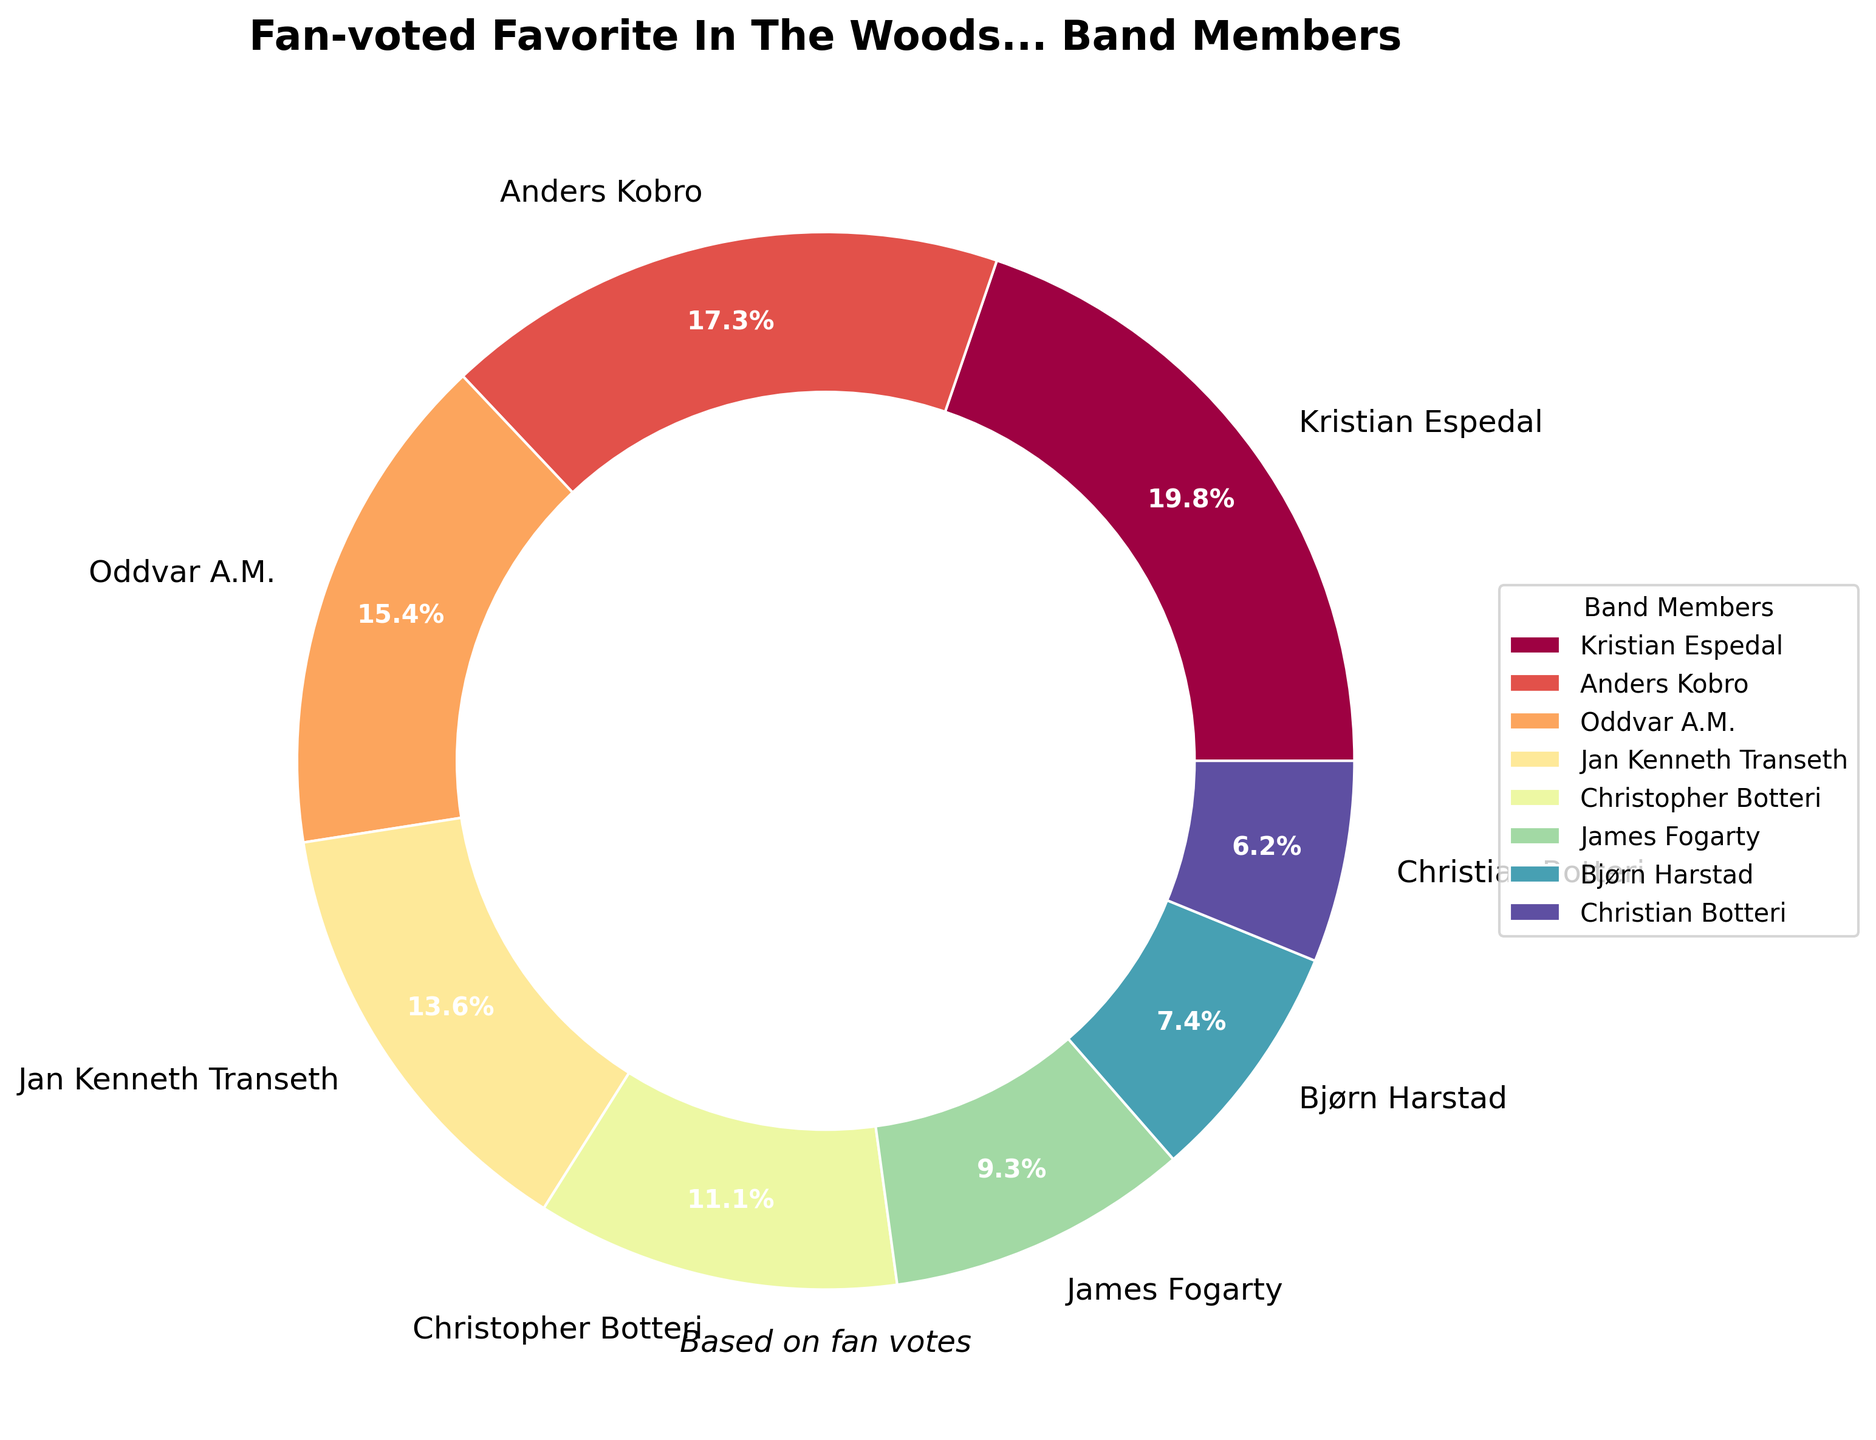What percentage of votes did Kristian Espedal receive? We can determine this by looking at the pie chart and noting the percentage label next to Kristian Espedal's name, which is 24.6%.
Answer: 24.6% Who received more votes, Oddvar A.M. or Jan Kenneth Transeth? We determine this by comparing the percentage labels next to Oddvar A.M. and Jan Kenneth Transeth in the pie chart. Oddvar A.M. has 19.2%, while Jan Kenneth Transeth has 16.9%. Therefore, Oddvar A.M. received more votes.
Answer: Oddvar A.M What is the total percentage of votes received by Anders Kobro and Christopher Botteri? Add the percentages for Anders Kobro and Christopher Botteri as given in the pie chart: 21.5% (Anders) + 13.8% (Christopher).
Answer: 35.3% Which band member received the fewest votes? We determine this by looking at who has the smallest percentage label in the pie chart. Christian Botteri received 7.7%, the smallest proportion.
Answer: Christian Botteri How many percentage points more did Kristian Espedal receive compared to James Fogarty? This is found by subtracting James Fogarty's percentage from Kristian Espedal's percentage. Kristian Espedal: 24.6%, James Fogarty: 11.5%. So, 24.6% - 11.5% = 13.1%.
Answer: 13.1% Are there any band members with roughly equal votes? By comparing the percentage labels for each member in the pie chart, we can see Anders Kobro has 21.5% and Oddvar A.M has 19.2%, which are relatively close.
Answer: Anders Kobro and Oddvar A.M Which members received less than 10% of the votes? We check the pie chart for members whose percentages are below 10%. Only Christian Botteri received less than 10%, which is 7.7%.
Answer: Christian Botteri What is the median percentage of votes received by the band members? First, we list the percentages in order: 7.7%, 9.2%, 11.5%, 13.8%, 16.9%, 19.2%, 21.5%, 24.6%. The middle two values are 13.8% and 16.9%, so the median is the average of these two: (13.8 + 16.9) / 2 = 15.35%.
Answer: 15.35% 